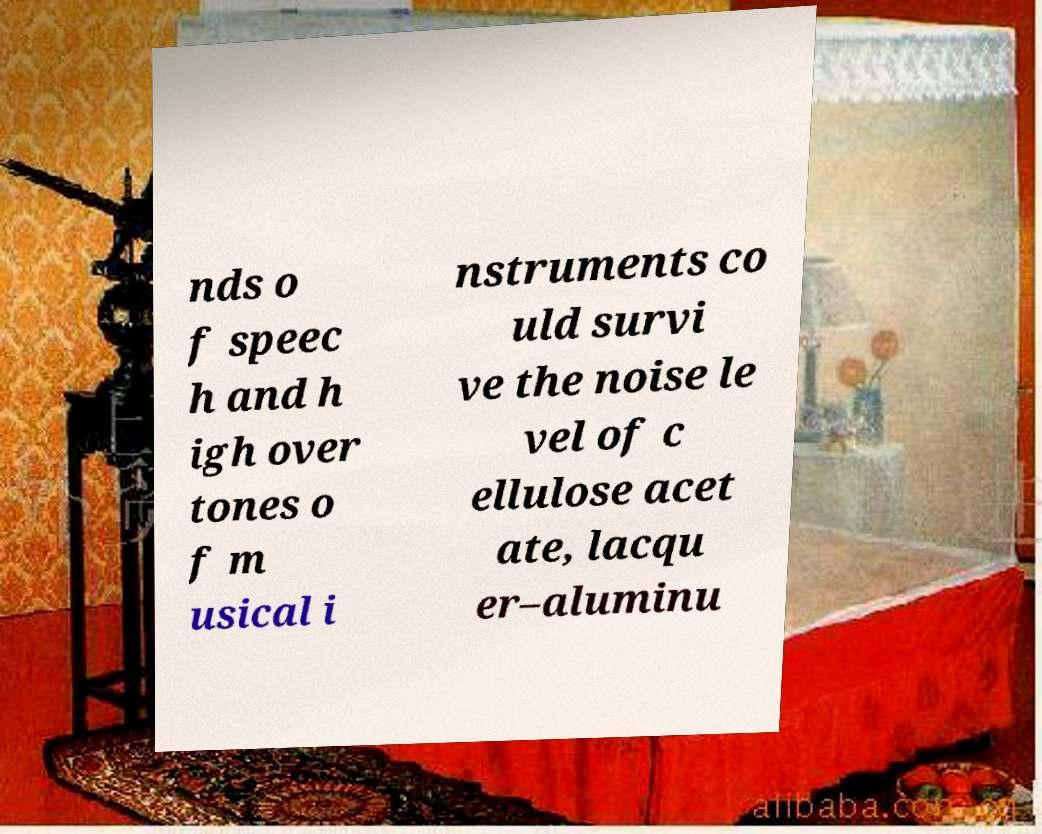Can you read and provide the text displayed in the image?This photo seems to have some interesting text. Can you extract and type it out for me? nds o f speec h and h igh over tones o f m usical i nstruments co uld survi ve the noise le vel of c ellulose acet ate, lacqu er–aluminu 